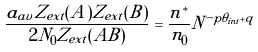<formula> <loc_0><loc_0><loc_500><loc_500>\frac { a _ { a v } Z _ { e x t } ( A ) Z _ { e x t } ( B ) } { 2 N _ { 0 } Z _ { e x t } ( A B ) } = \frac { n ^ { * } } { n _ { 0 } } N ^ { - p \theta _ { i n t } + q }</formula> 